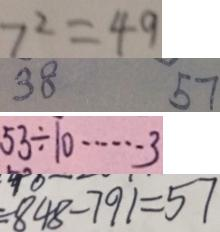Convert formula to latex. <formula><loc_0><loc_0><loc_500><loc_500>7 ^ { 2 } = 4 9 
 3 8 5 7 
 5 3 \div 1 0 \cdots 3 
 8 4 8 - 7 9 1 = 5 7</formula> 